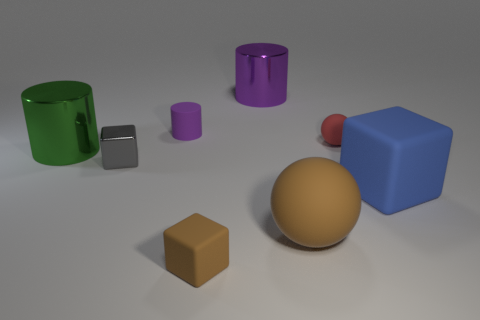Add 2 large shiny cylinders. How many objects exist? 10 Subtract all balls. How many objects are left? 6 Subtract 1 brown balls. How many objects are left? 7 Subtract all big cyan matte cylinders. Subtract all shiny cylinders. How many objects are left? 6 Add 7 small cylinders. How many small cylinders are left? 8 Add 6 shiny cubes. How many shiny cubes exist? 7 